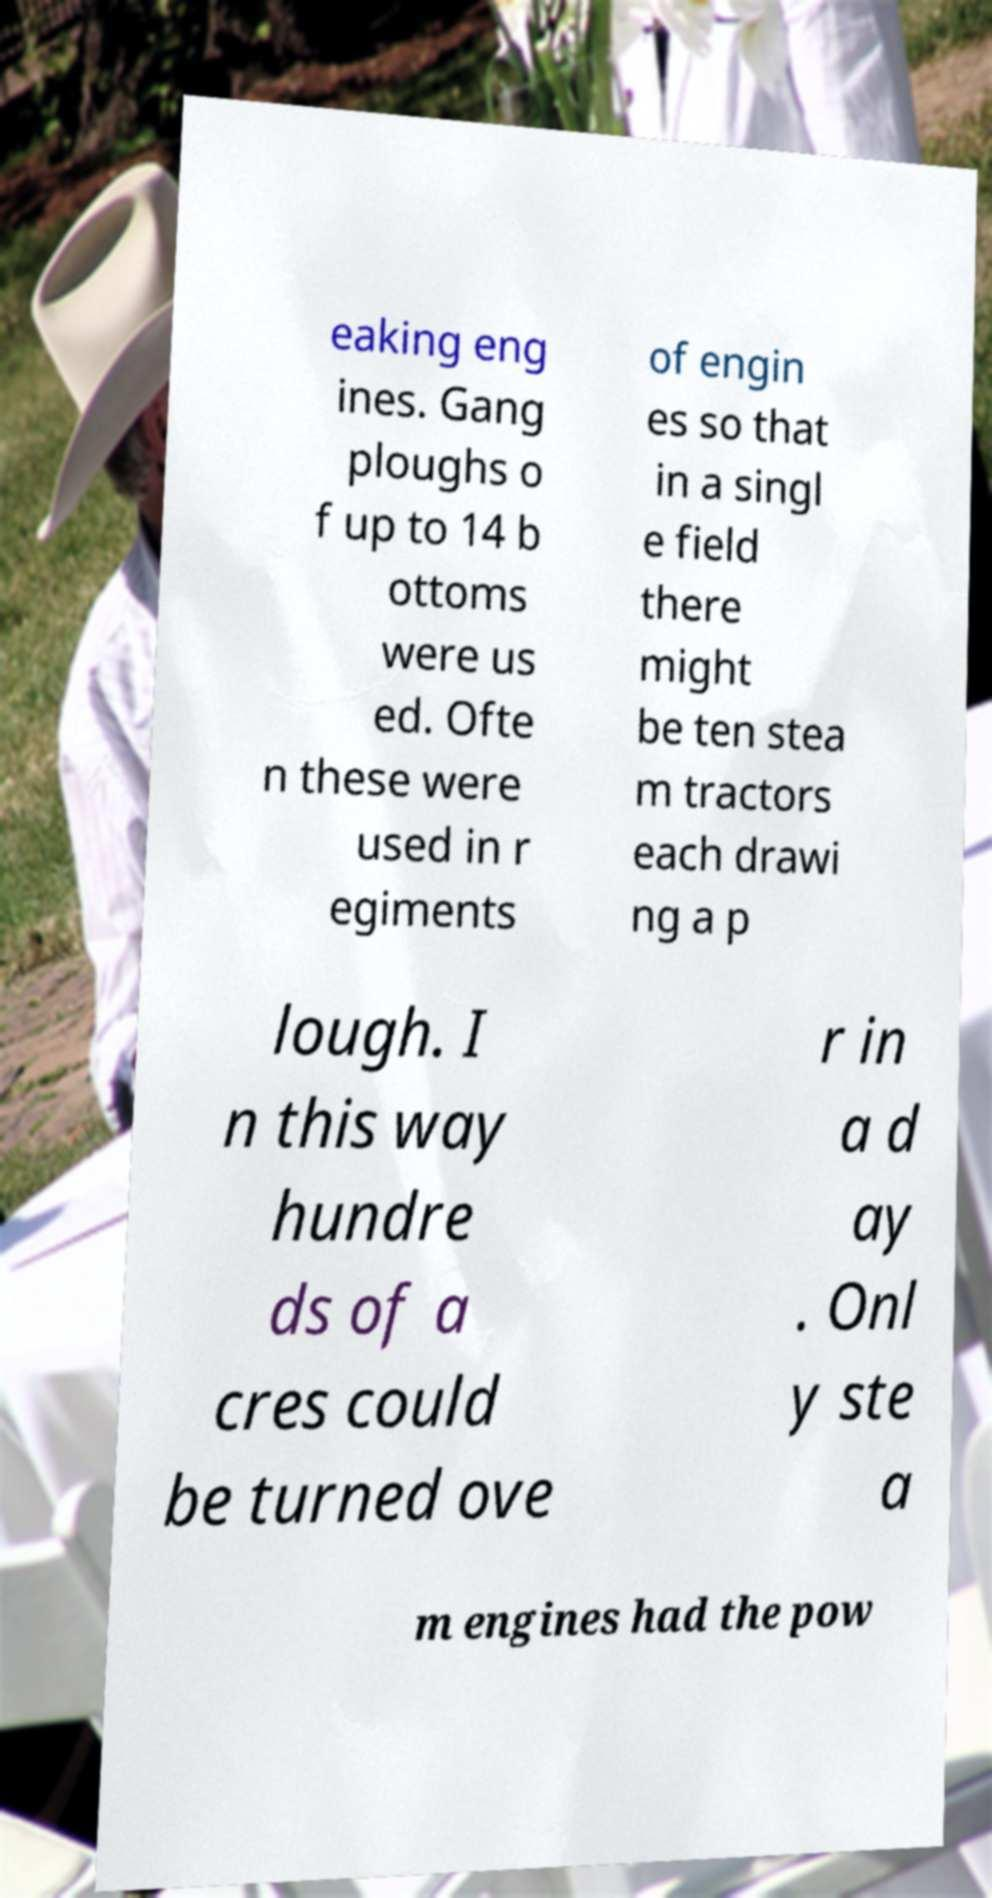I need the written content from this picture converted into text. Can you do that? eaking eng ines. Gang ploughs o f up to 14 b ottoms were us ed. Ofte n these were used in r egiments of engin es so that in a singl e field there might be ten stea m tractors each drawi ng a p lough. I n this way hundre ds of a cres could be turned ove r in a d ay . Onl y ste a m engines had the pow 